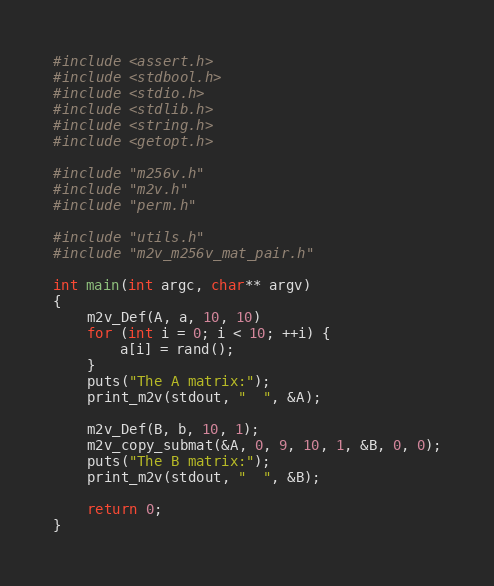<code> <loc_0><loc_0><loc_500><loc_500><_C_>#include <assert.h>
#include <stdbool.h>
#include <stdio.h>
#include <stdlib.h>
#include <string.h>
#include <getopt.h>

#include "m256v.h"
#include "m2v.h"
#include "perm.h"

#include "utils.h"
#include "m2v_m256v_mat_pair.h"

int main(int argc, char** argv)
{
	m2v_Def(A, a, 10, 10)
	for (int i = 0; i < 10; ++i) {
		a[i] = rand();
	}
	puts("The A matrix:");
	print_m2v(stdout, "  ", &A);

	m2v_Def(B, b, 10, 1);
	m2v_copy_submat(&A, 0, 9, 10, 1, &B, 0, 0);
	puts("The B matrix:");
	print_m2v(stdout, "  ", &B);

	return 0;
}
</code> 